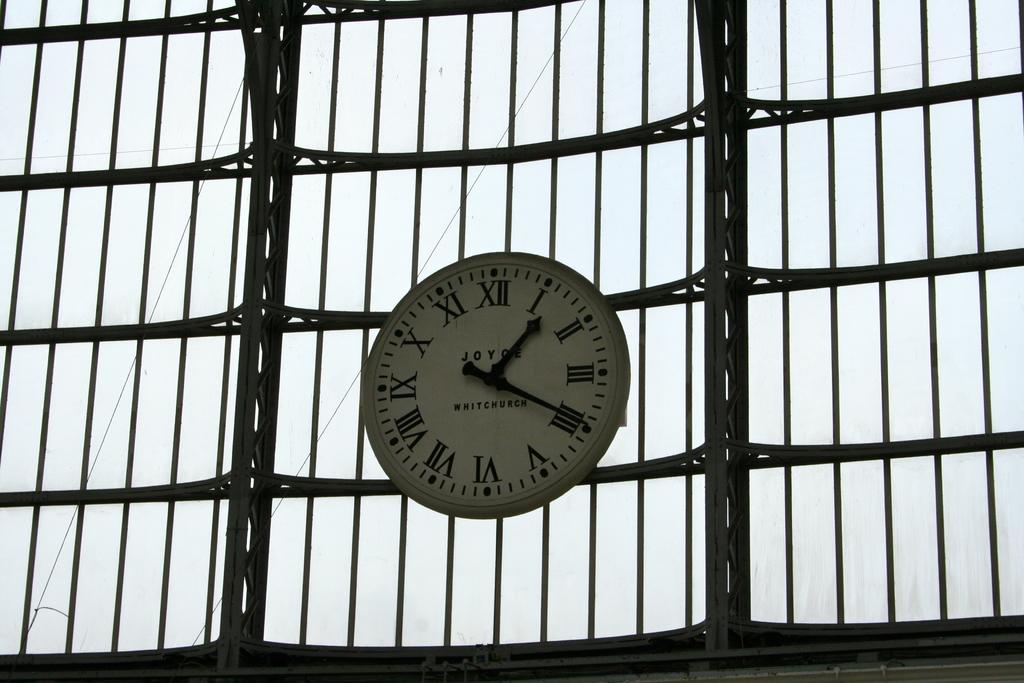Is the time 1:20?
Offer a very short reply. Yes. 